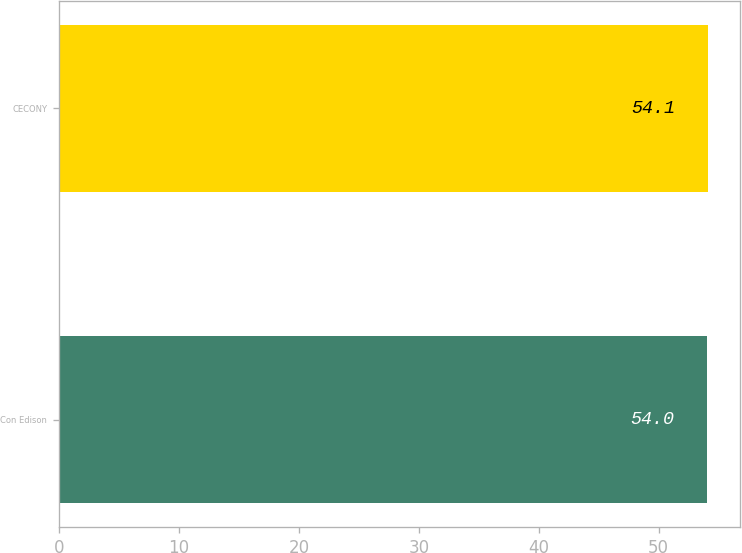Convert chart to OTSL. <chart><loc_0><loc_0><loc_500><loc_500><bar_chart><fcel>Con Edison<fcel>CECONY<nl><fcel>54<fcel>54.1<nl></chart> 